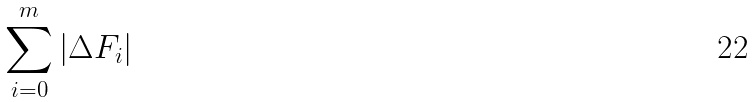<formula> <loc_0><loc_0><loc_500><loc_500>\sum _ { i = 0 } ^ { m } | \Delta F _ { i } |</formula> 